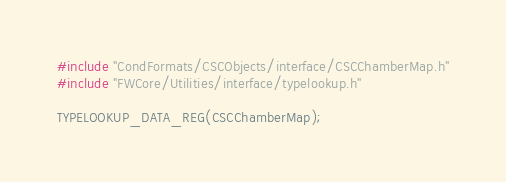<code> <loc_0><loc_0><loc_500><loc_500><_C++_>#include "CondFormats/CSCObjects/interface/CSCChamberMap.h"
#include "FWCore/Utilities/interface/typelookup.h"

TYPELOOKUP_DATA_REG(CSCChamberMap);

</code> 